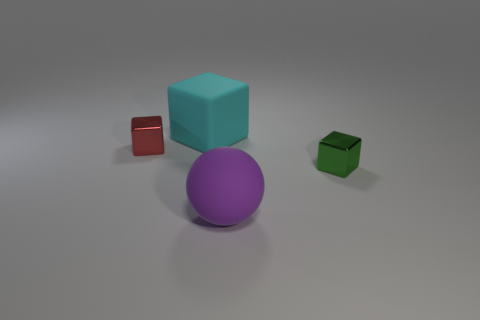Is there anything else that has the same size as the green metal block?
Ensure brevity in your answer.  Yes. What is the object that is to the right of the matte block and behind the big ball made of?
Your answer should be very brief. Metal. What number of other objects are there of the same material as the purple thing?
Make the answer very short. 1. What is the size of the shiny cube that is to the right of the small object on the left side of the small metal cube to the right of the cyan matte object?
Keep it short and to the point. Small. How many matte things are blocks or cyan cubes?
Give a very brief answer. 1. Do the cyan object and the metal thing on the right side of the small red shiny cube have the same shape?
Your answer should be compact. Yes. Are there more blocks that are right of the large purple thing than big cyan cubes that are left of the matte cube?
Your response must be concise. Yes. Is there any other thing of the same color as the large sphere?
Your answer should be compact. No. There is a red metal block on the left side of the matte thing to the left of the large rubber sphere; are there any big things that are left of it?
Ensure brevity in your answer.  No. There is a big rubber object that is left of the large purple ball; does it have the same shape as the large purple object?
Make the answer very short. No. 